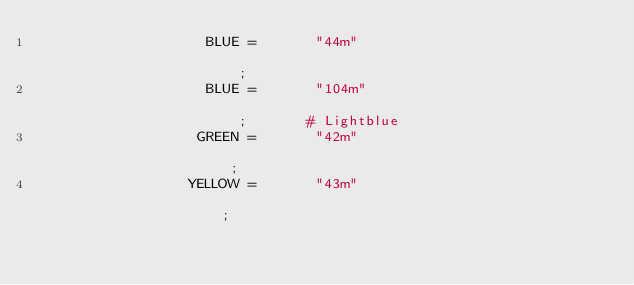<code> <loc_0><loc_0><loc_500><loc_500><_Bash_>                    BLUE =       "44m"                                                  ;
                    BLUE =       "104m"                                                 ;       # Lightblue
                   GREEN =       "42m"                                                  ;
                  YELLOW =       "43m"                                                  ;</code> 